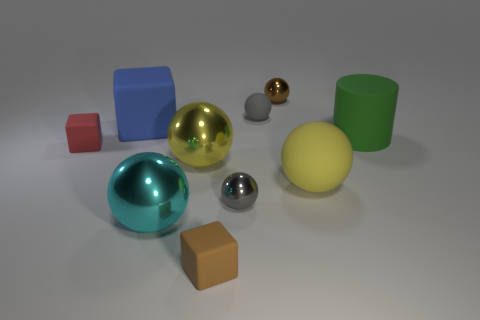Subtract all large yellow metal balls. How many balls are left? 5 Subtract all brown spheres. How many spheres are left? 5 Subtract all gray balls. Subtract all blue cylinders. How many balls are left? 4 Subtract all balls. How many objects are left? 4 Add 3 gray metal things. How many gray metal things are left? 4 Add 3 big balls. How many big balls exist? 6 Subtract 0 yellow blocks. How many objects are left? 10 Subtract all red matte cubes. Subtract all tiny gray things. How many objects are left? 7 